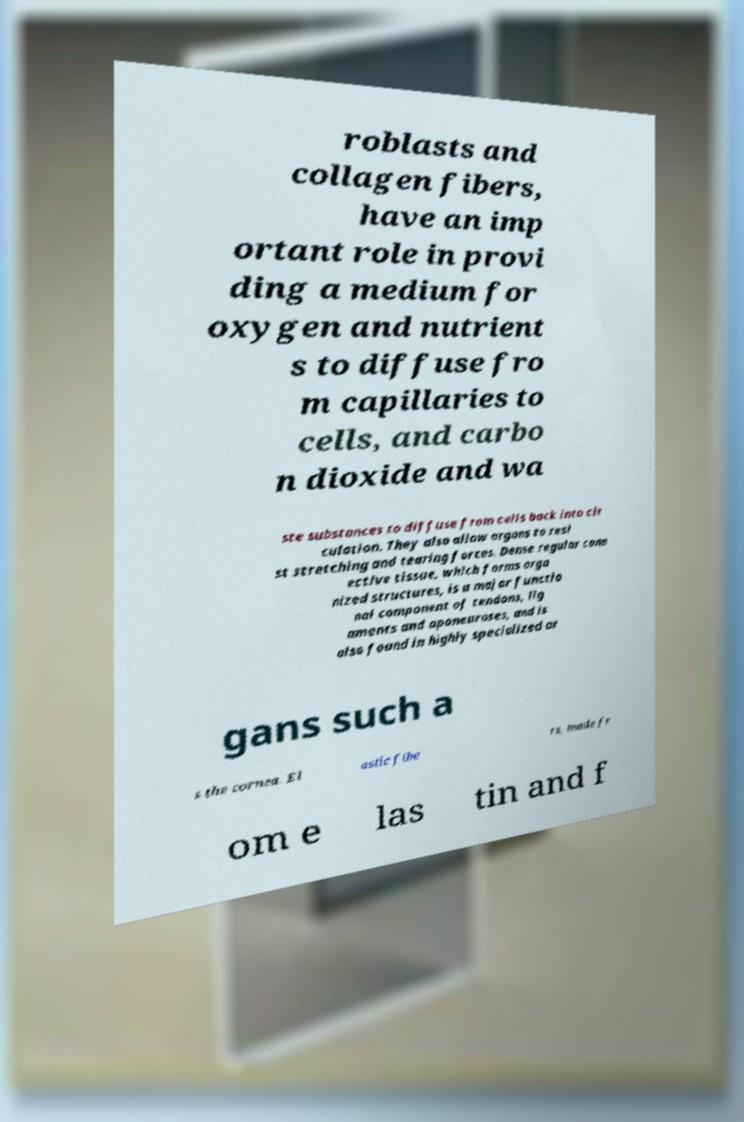Could you assist in decoding the text presented in this image and type it out clearly? roblasts and collagen fibers, have an imp ortant role in provi ding a medium for oxygen and nutrient s to diffuse fro m capillaries to cells, and carbo n dioxide and wa ste substances to diffuse from cells back into cir culation. They also allow organs to resi st stretching and tearing forces. Dense regular conn ective tissue, which forms orga nized structures, is a major functio nal component of tendons, lig aments and aponeuroses, and is also found in highly specialized or gans such a s the cornea. El astic fibe rs, made fr om e las tin and f 